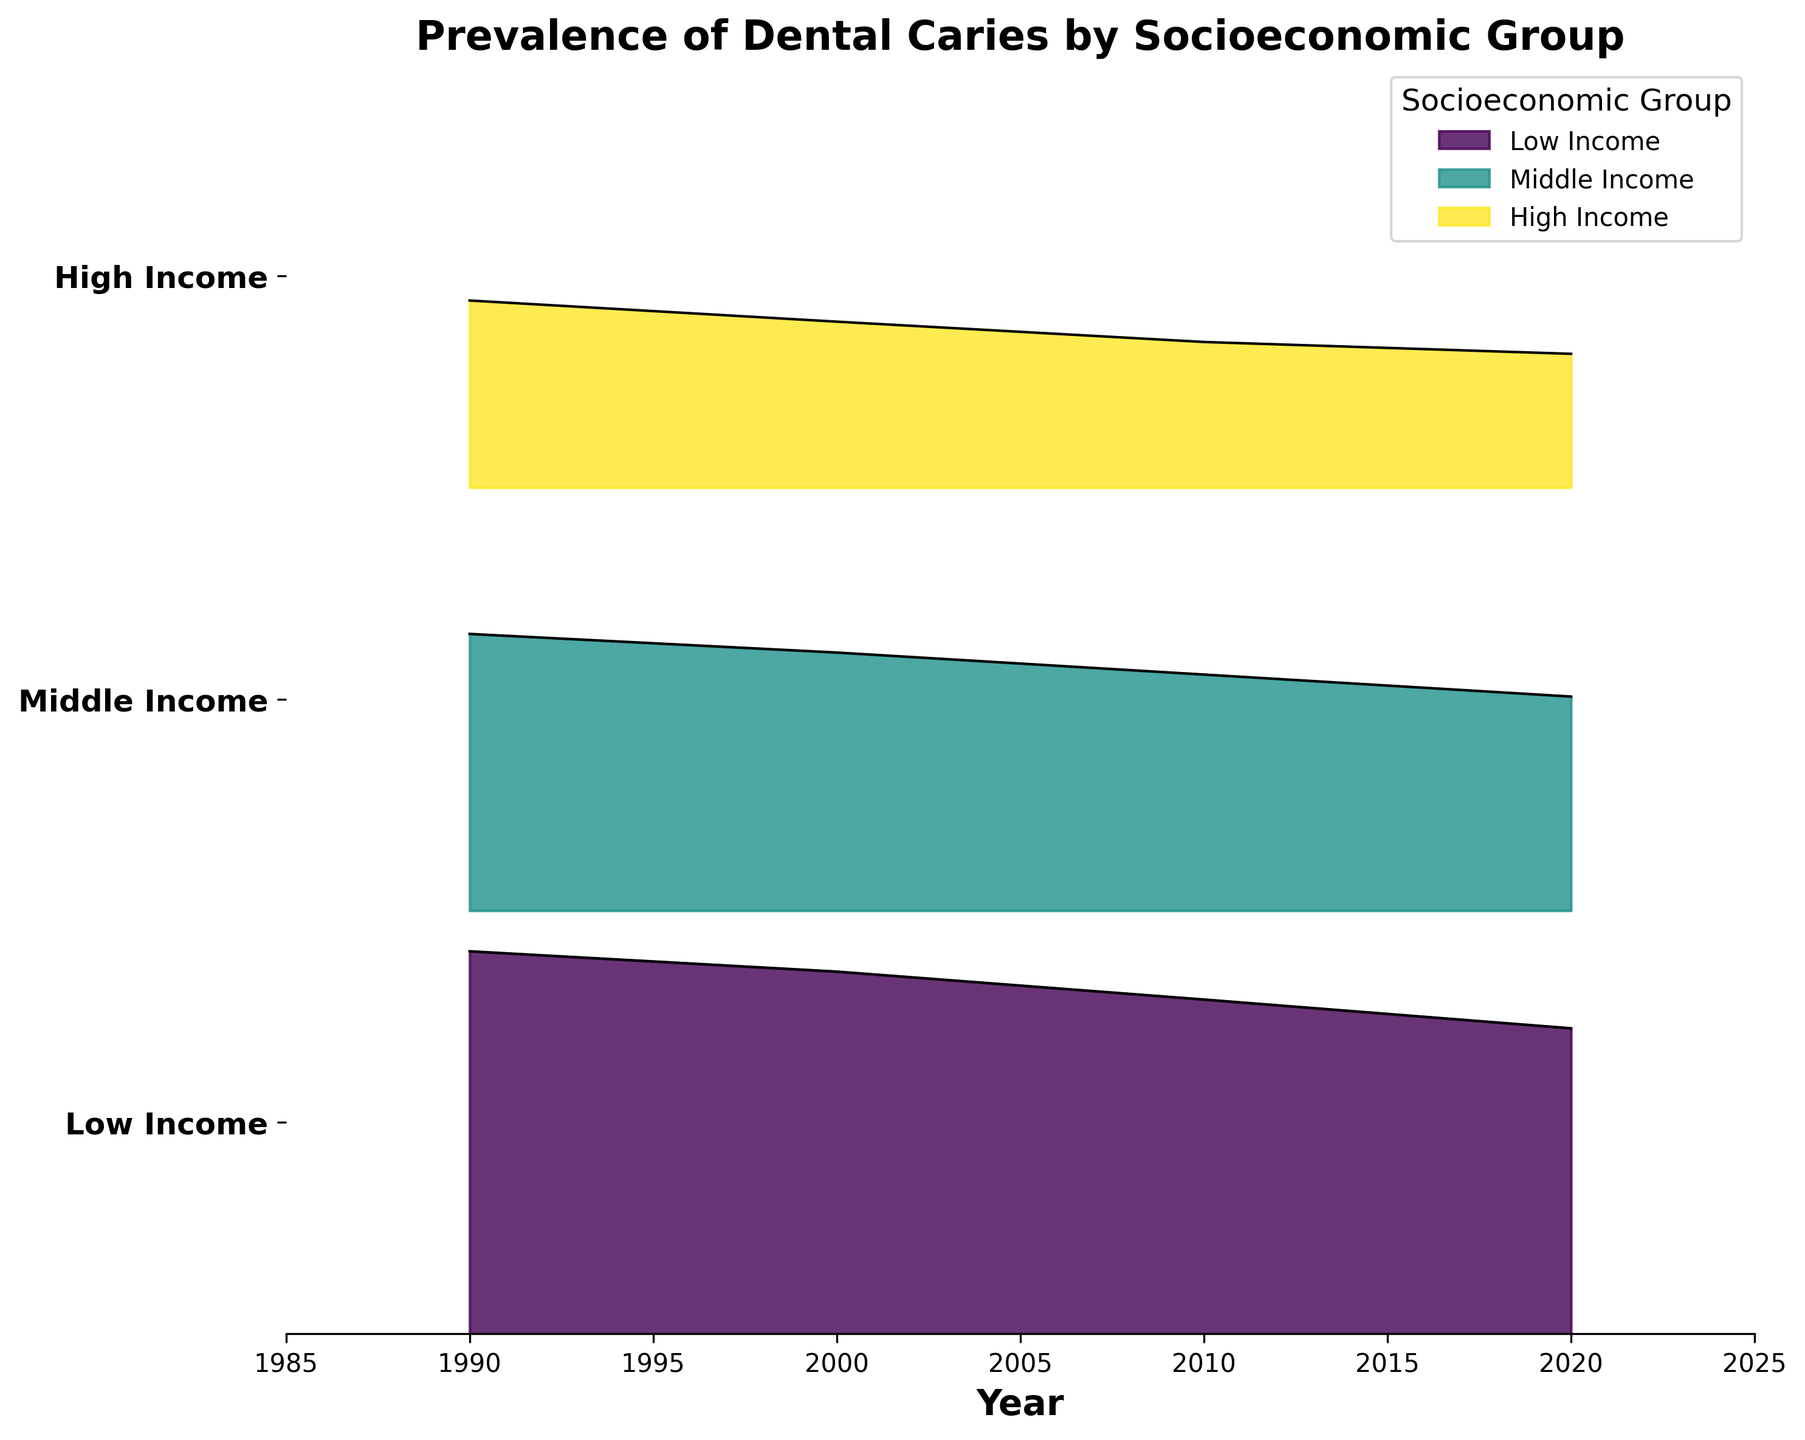What is the title of the figure? The title is found at the top of the figure, usually in a larger and bold font compared to the rest of the text. It directly describes what the plot is about.
Answer: Prevalence of Dental Caries by Socioeconomic Group Which socioeconomic group had the highest prevalence of dental caries in 1990? To find this, we look at the values on the ridgeline plot for the year 1990 and identify the group with the highest prevalence indicated.
Answer: Low Income How does the prevalence of dental caries for the Low Income group change from 1990 to 2020? Check the line or filled area for Low Income from 1990 to 2020. Look at the y-values at these two points and compare them to see the trend.
Answer: It decreases Which socioeconomic group had the lowest prevalence of dental caries in 2020? Identify the group with the lowest peak in the ridgeline plot for the year 2020.
Answer: High Income By how many percentage points did the prevalence of dental caries in the Middle Income group decrease from 1990 to 2000? Look at the prevalence value for Middle Income in 1990 and subtract the value in 2000.
Answer: 2.2 percentage points Among the socioeconomic groups, which group shows the most significant decrease in dental caries prevalence from 1990 to 2020? Calculate the difference in prevalence from 1990 to 2020 for each group. Compare these differences to find the largest decrease.
Answer: Low Income Is the general trend in the prevalence of dental caries over time increasing or decreasing for all socioeconomic groups? Observe the direction of the lines or filled areas from 1990 to 2020 for all groups and determine if they show an overall upward or downward trend.
Answer: Decreasing Compare the prevalence of dental caries in the Middle Income group in 1990 and 2010. How does it change? Find and compare the prevalence values for Middle Income in 1990 and 2010. Identify whether it increased or decreased and by how much.
Answer: Decreased by 4.8 percentage points Which year did the High Income group reach a prevalence below 20% for the first time? Look at the prevalence values for the High Income group across the years and identify the first year when it dropped below 20%.
Answer: 2000 By what percentage has the prevalence of dental caries in the High Income group reduced from 1990 to 2020? Calculate the percentage reduction by taking the difference in prevalence from 1990 to 2020, dividing by the 1990 prevalence, and multiplying by 100 to get the percentage.
Answer: 28.5% 